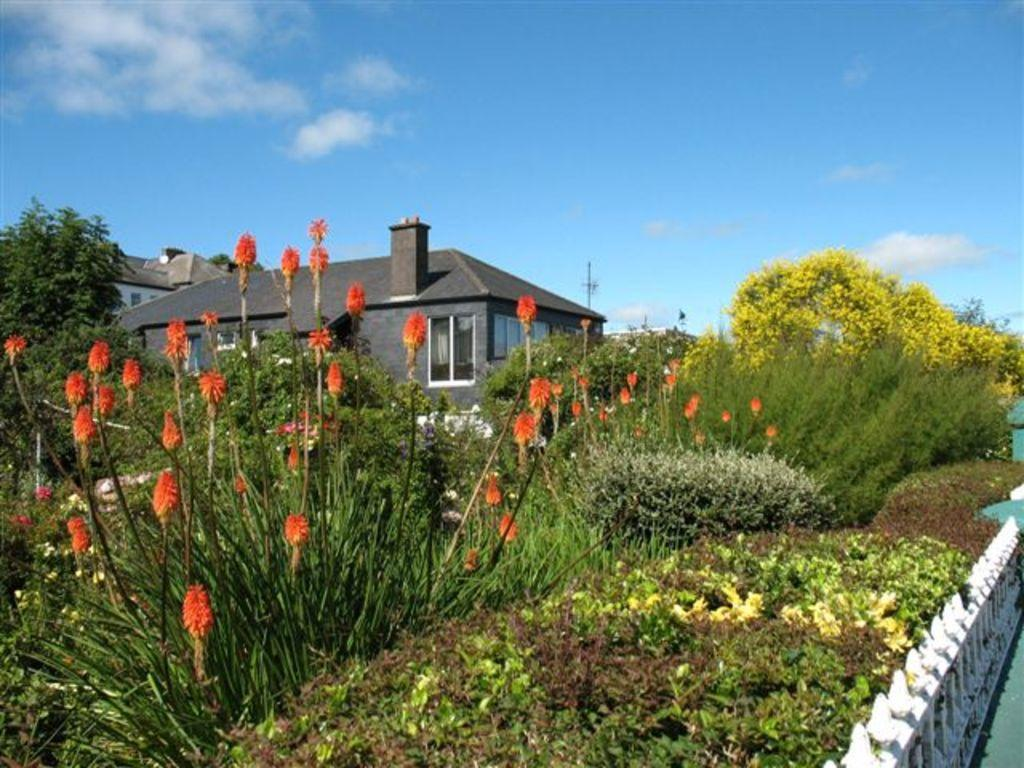What types of vegetation can be seen in the image? There are various plants and flowers in the image. Are there any tall plants or trees in the image? Yes, there are trees in the image. What can be seen in the background of the image? There is a building in the background of the image. What is the condition of the sky in the image? The sky is clear in the image. Can you see a frog hopping on the mountain in the image? There is no mountain or frog present in the image. 